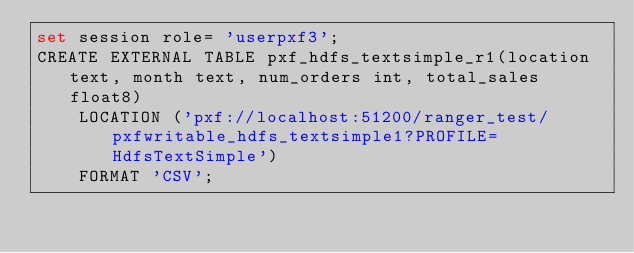<code> <loc_0><loc_0><loc_500><loc_500><_SQL_>set session role= 'userpxf3';
CREATE EXTERNAL TABLE pxf_hdfs_textsimple_r1(location text, month text, num_orders int, total_sales float8)
	LOCATION ('pxf://localhost:51200/ranger_test/pxfwritable_hdfs_textsimple1?PROFILE=HdfsTextSimple')
	FORMAT 'CSV';
</code> 